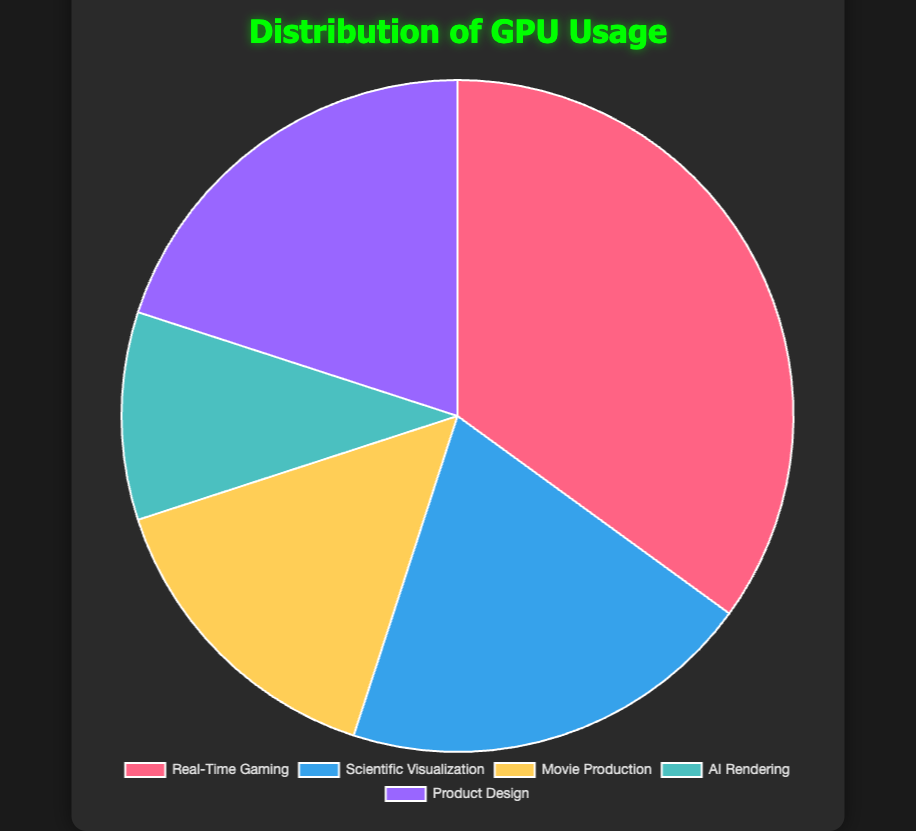What percentage of GPU usage is dedicated to non-gaming purposes? First, identify the percentage dedicated to Real-Time Gaming, which is 35%. Then sum the percentages for the other types: Scientific Visualization (20%), Movie Production (15%), AI Rendering (10%), and Product Design (20%). The total non-gaming usage is 20% + 15% + 10% + 20% = 65%.
Answer: 65% What is the difference in percentage between Real-Time Gaming and AI Rendering? Real-Time Gaming usage is 35%, and AI Rendering usage is 10%. Subtract AI Rendering from Real-Time Gaming: 35% - 10% = 25%.
Answer: 25% Which type of rendering uses the GPU the least? By examining the values, AI Rendering has the lowest percentage at 10%.
Answer: AI Rendering What percentage does Scientific Visualization and Product Design together occupy in GPU usage? Add the percentages of Scientific Visualization and Product Design: 20% + 20% = 40%.
Answer: 40% Which segment has the largest visual representation in the pie chart? The largest segment is the one representing Real-Time Gaming with a 35% usage.
Answer: Real-Time Gaming Compare the GPU usage of Movie Production and Scientific Visualization. Which is greater and by how much? Movie Production uses 15% and Scientific Visualization uses 20%. Scientific Visualization is greater by 20% - 15% = 5%.
Answer: Scientific Visualization; 5% What is the average percentage of GPU usage across all the categories? Sum all the percentages: 35% + 20% + 15% + 10% + 20% = 100%. Divide by the number of categories: 100% / 5 = 20%.
Answer: 20% If the total available GPU usage is 100 units, how many units are used by Product Design? Product Design uses 20% of the total. Therefore, 20% of 100 units is 100 * 0.20 = 20 units.
Answer: 20 units Identify the colored section for Movie Production without knowing its specific color name. Movie Production usage is 15%, and it is the fourth segment in the order described in the data. Identify the fourth segment visually.
Answer: Fourth segment in order 